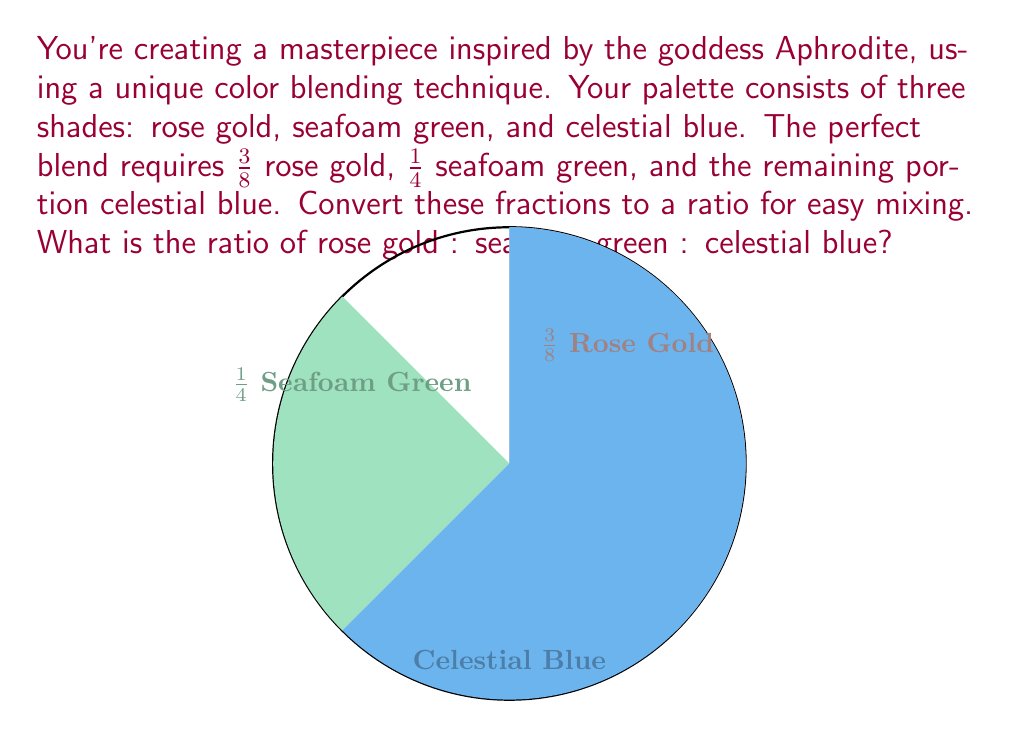Can you solve this math problem? Let's approach this step-by-step:

1) First, we need to find the fraction of celestial blue:
   $$1 - (\frac{3}{8} + \frac{1}{4}) = 1 - (\frac{3}{8} + \frac{2}{8}) = 1 - \frac{5}{8} = \frac{3}{8}$$

2) Now we have all three fractions:
   Rose gold: $\frac{3}{8}$
   Seafoam green: $\frac{1}{4} = \frac{2}{8}$
   Celestial blue: $\frac{3}{8}$

3) To convert fractions to a ratio, we need to find a common denominator (which is already 8) and use the numerators:

   $\frac{3}{8} : \frac{2}{8} : \frac{3}{8}$ simplifies to $3 : 2 : 3$

4) This ratio 3:2:3 represents the proportions of rose gold, seafoam green, and celestial blue respectively.
Answer: 3:2:3 